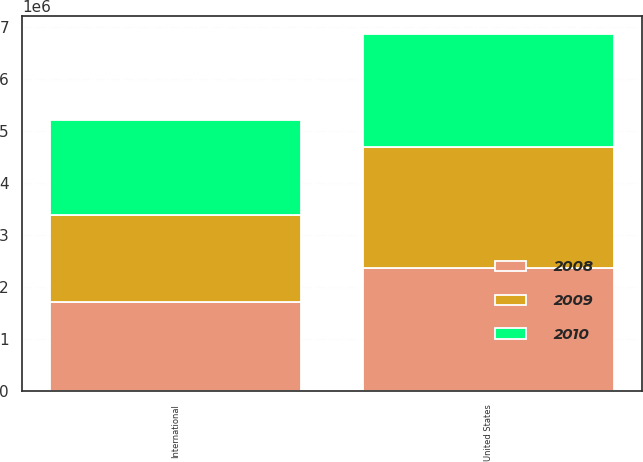Convert chart to OTSL. <chart><loc_0><loc_0><loc_500><loc_500><stacked_bar_chart><ecel><fcel>United States<fcel>International<nl><fcel>2010<fcel>2.17327e+06<fcel>1.8289e+06<nl><fcel>2008<fcel>2.36356e+06<fcel>1.70439e+06<nl><fcel>2009<fcel>2.33917e+06<fcel>1.68235e+06<nl></chart> 